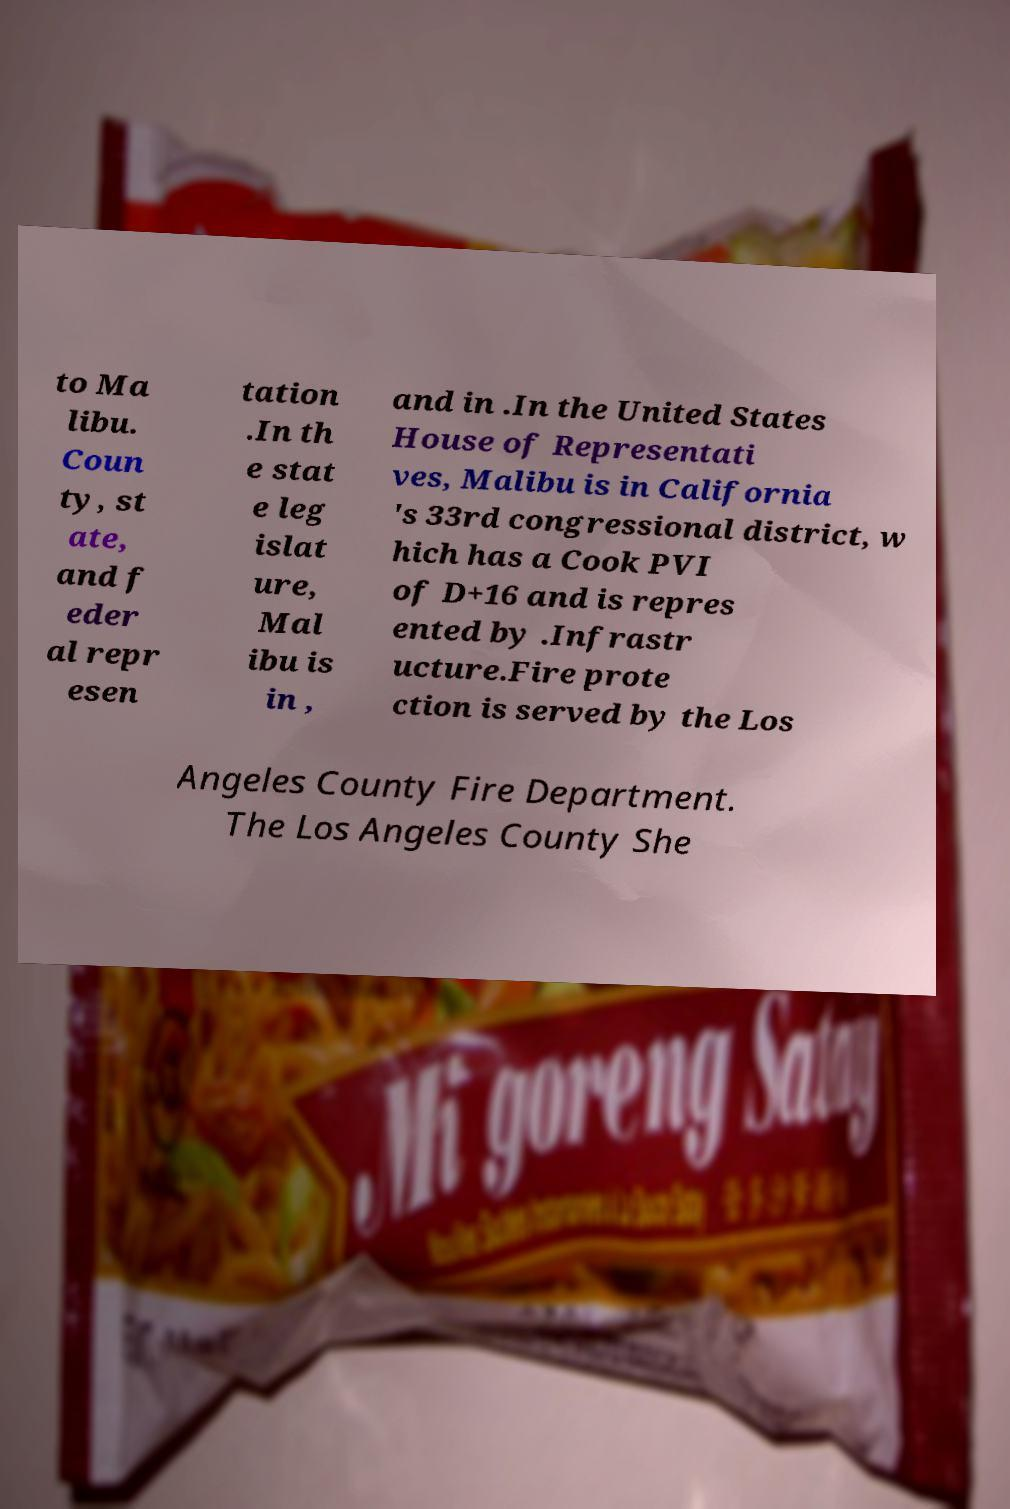Can you read and provide the text displayed in the image?This photo seems to have some interesting text. Can you extract and type it out for me? to Ma libu. Coun ty, st ate, and f eder al repr esen tation .In th e stat e leg islat ure, Mal ibu is in , and in .In the United States House of Representati ves, Malibu is in California 's 33rd congressional district, w hich has a Cook PVI of D+16 and is repres ented by .Infrastr ucture.Fire prote ction is served by the Los Angeles County Fire Department. The Los Angeles County She 